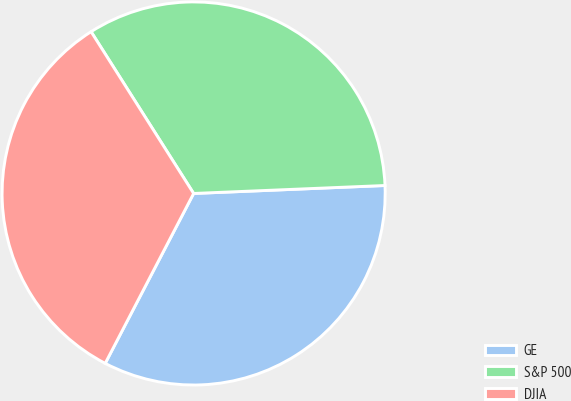Convert chart. <chart><loc_0><loc_0><loc_500><loc_500><pie_chart><fcel>GE<fcel>S&P 500<fcel>DJIA<nl><fcel>33.3%<fcel>33.33%<fcel>33.37%<nl></chart> 